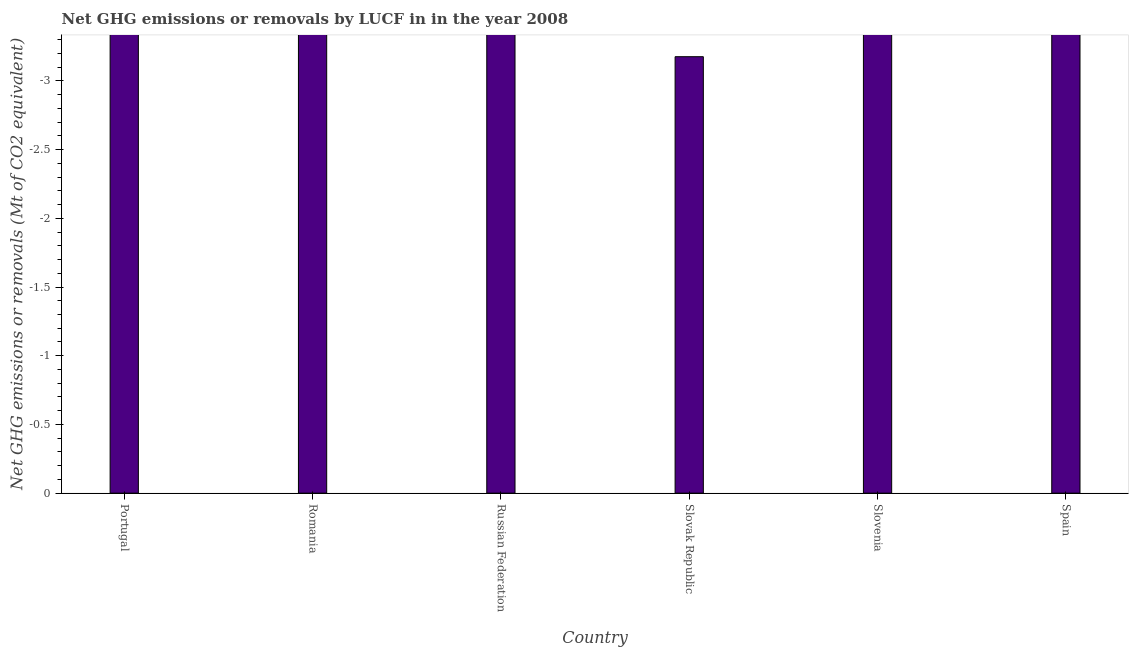Does the graph contain grids?
Give a very brief answer. No. What is the title of the graph?
Give a very brief answer. Net GHG emissions or removals by LUCF in in the year 2008. What is the label or title of the X-axis?
Keep it short and to the point. Country. What is the label or title of the Y-axis?
Make the answer very short. Net GHG emissions or removals (Mt of CO2 equivalent). What is the average ghg net emissions or removals per country?
Offer a terse response. 0. What is the median ghg net emissions or removals?
Give a very brief answer. 0. In how many countries, is the ghg net emissions or removals greater than the average ghg net emissions or removals taken over all countries?
Offer a terse response. 0. How many bars are there?
Make the answer very short. 0. Are all the bars in the graph horizontal?
Provide a succinct answer. No. How many countries are there in the graph?
Your answer should be very brief. 6. Are the values on the major ticks of Y-axis written in scientific E-notation?
Give a very brief answer. No. What is the Net GHG emissions or removals (Mt of CO2 equivalent) of Portugal?
Provide a short and direct response. 0. What is the Net GHG emissions or removals (Mt of CO2 equivalent) of Russian Federation?
Provide a short and direct response. 0. 